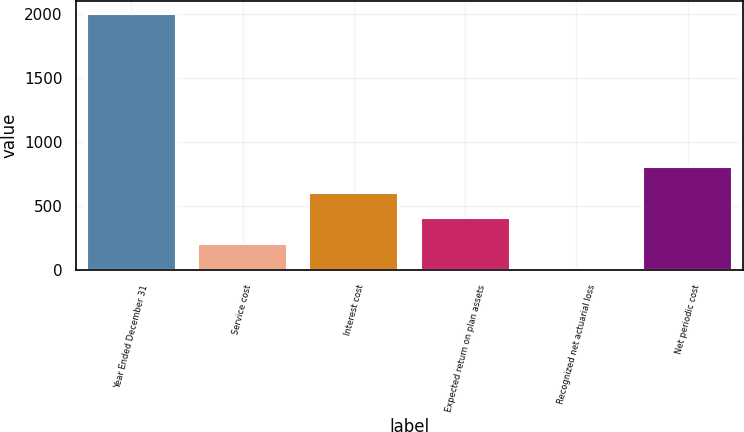<chart> <loc_0><loc_0><loc_500><loc_500><bar_chart><fcel>Year Ended December 31<fcel>Service cost<fcel>Interest cost<fcel>Expected return on plan assets<fcel>Recognized net actuarial loss<fcel>Net periodic cost<nl><fcel>2005<fcel>209.5<fcel>608.5<fcel>409<fcel>10<fcel>808<nl></chart> 